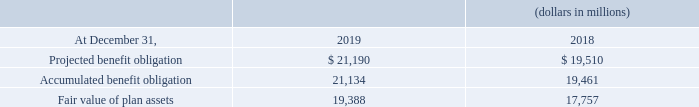2016 Collective Bargaining Negotiations
During 2016, we adopted changes to our defined benefit pension plans and other postretirement benefit plans to reflect the agreed upon terms and conditions of the collective bargaining agreements ratified in June 2016. The impact includes a net increase to Accumulated other comprehensive income of $2.9 billion (net of taxes of $1.8 billion).
The amount recorded in Accumulated other comprehensive income will be reclassified to net periodic benefit cost on a straight-line basis over the average remaining service period of the respective plans’ participants, which, on a weighted-average basis, is 12.2 years for defined benefit pension plans and 7.8 years for other postretirement benefit plans.
The above-noted reclassification resulted in a decrease to net periodic benefit cost and increase to pre-tax income of approximately $658 million during 2019, 2018 and 2017, respectively. Information for pension plans with an accumulated benefit obligation in excess of plan assets follows:
Information for pension plans with an accumulated benefit obligation in excess of plan assets follows:
What was the net increase to accumulated other comprehensive income in 2016? $2.9 billion. What is the duration of postretirement benefit plan over which the amount will be reclassified? 7.8 years. What was the projected benefit obligation in 2019?
Answer scale should be: million. $ 21,190. What is the change in the projected benefit obligation from 2018 to 2019?
Answer scale should be: million. 21,190 - 19,510
Answer: 1680. What was the average accumulated benefit obligation for 2018 and 2019?
Answer scale should be: million. (21,134 + 19,461) / 2
Answer: 20297.5. What was the percentage change in the fair value of plan assets from 2018 to 2019?
Answer scale should be: percent. 19,388 / 17,757 - 1
Answer: 9.19. 